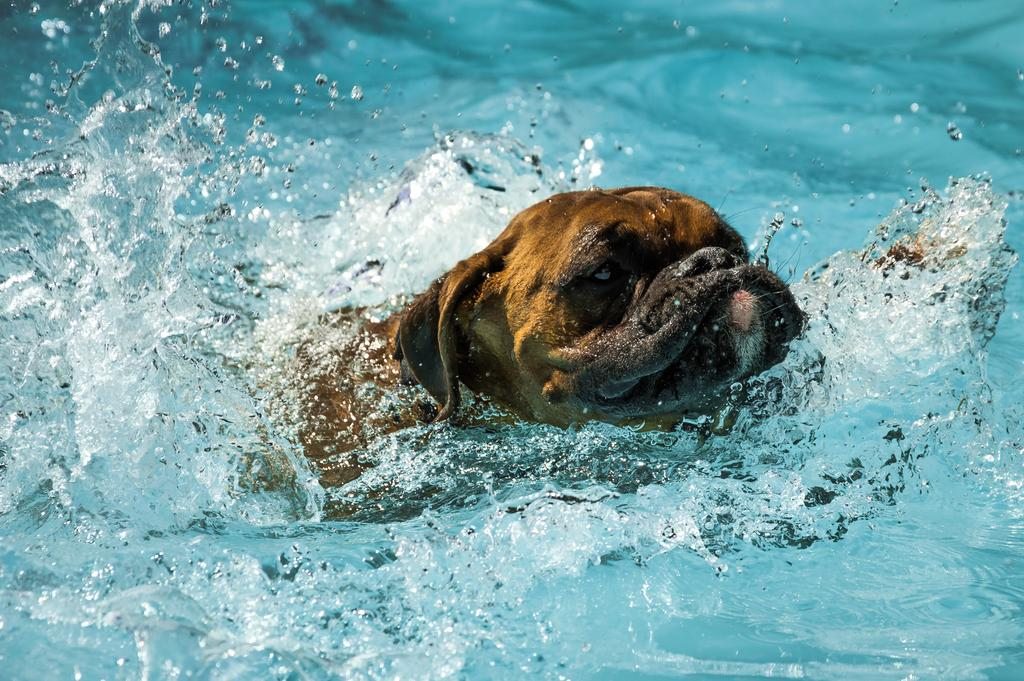What animal is present in the image? There is a dog in the image. Where is the dog located in the image? The dog is in the water. What flavor of shoes can be seen on the dog's paws in the image? There are no shoes present in the image, and therefore no flavor can be associated with them. 